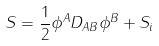<formula> <loc_0><loc_0><loc_500><loc_500>S = \frac { 1 } { 2 } \phi ^ { A } D _ { A B } \phi ^ { B } + S _ { i }</formula> 